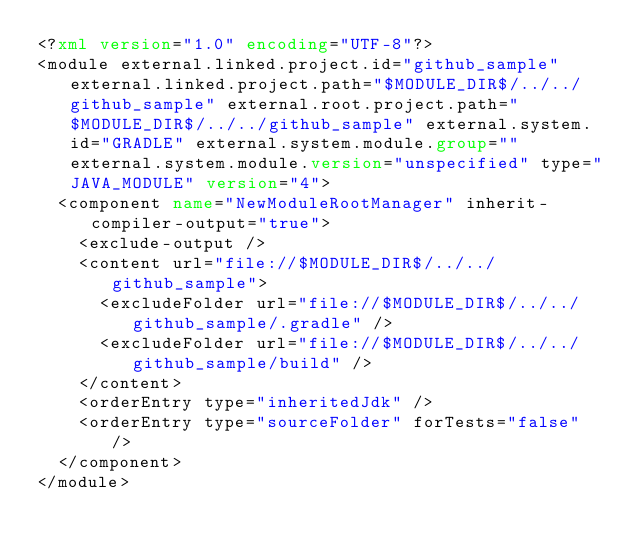<code> <loc_0><loc_0><loc_500><loc_500><_XML_><?xml version="1.0" encoding="UTF-8"?>
<module external.linked.project.id="github_sample" external.linked.project.path="$MODULE_DIR$/../../github_sample" external.root.project.path="$MODULE_DIR$/../../github_sample" external.system.id="GRADLE" external.system.module.group="" external.system.module.version="unspecified" type="JAVA_MODULE" version="4">
  <component name="NewModuleRootManager" inherit-compiler-output="true">
    <exclude-output />
    <content url="file://$MODULE_DIR$/../../github_sample">
      <excludeFolder url="file://$MODULE_DIR$/../../github_sample/.gradle" />
      <excludeFolder url="file://$MODULE_DIR$/../../github_sample/build" />
    </content>
    <orderEntry type="inheritedJdk" />
    <orderEntry type="sourceFolder" forTests="false" />
  </component>
</module></code> 